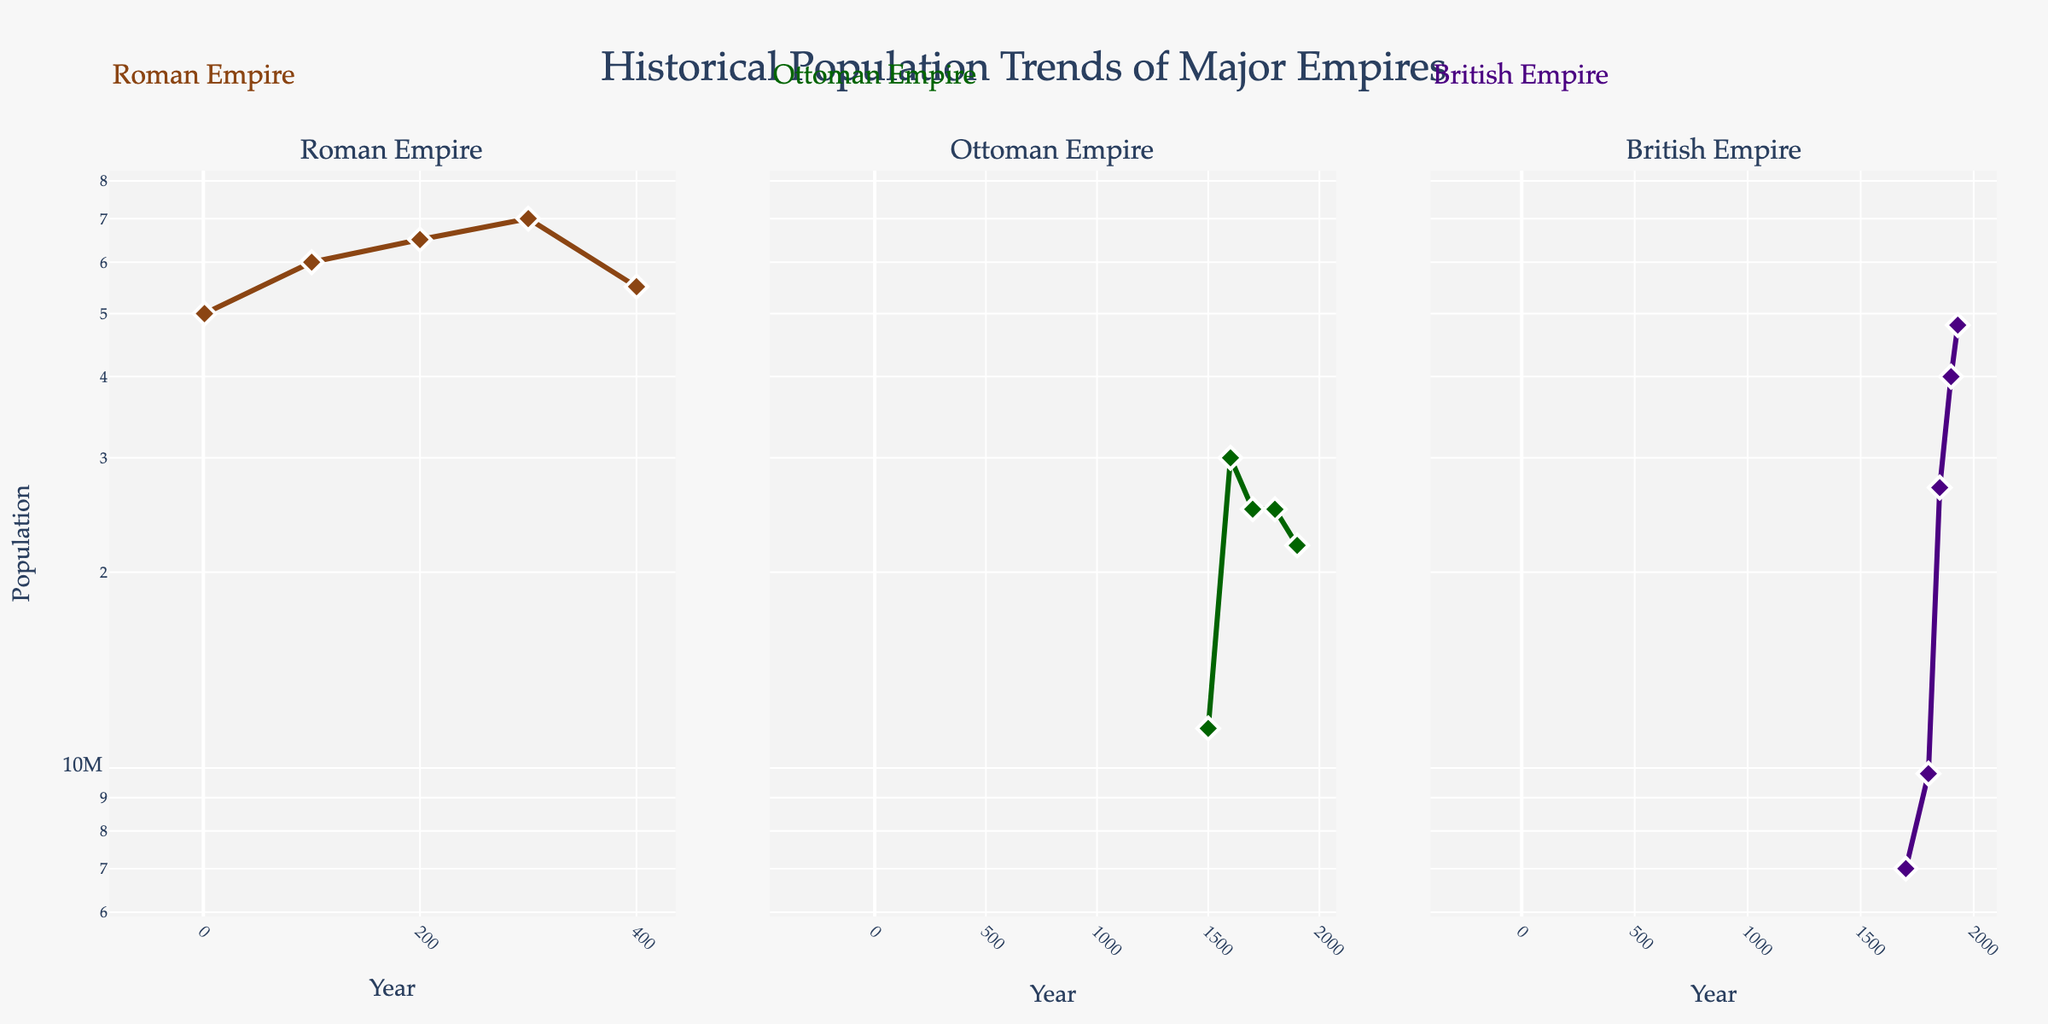How many empires are compared in the figure? The figure has three subplot titles, each representing a different empire. So, we count the subplot titles to find the number of empires.
Answer: Three Which empire has the highest population in its peak year? The Roman Empire's highest population appears to be around 70,000,000, which is higher than the peaks of the Ottoman and British Empires.
Answer: Roman Empire What is the population of the Ottoman Empire in the year 1600? By locating the year 1600 on the x-axis of the Ottoman Empire subplot, we see the population at that point is approximately 30,000,000.
Answer: 30,000,000 Between which years did the British Empire experience the most significant population growth? By examining the British Empire subplot, we notice the most significant jump is between 1800 and 1850, from about 9,800,000 to 27,000,000.
Answer: Between 1800 and 1850 Which empire shows a decline in population in the 1900s? Comparing all three subplots, the Ottoman Empire shows a decline in population from 25,000,000 in 1800 to 22,000,000 in 1900.
Answer: Ottoman Empire How does the population in 100 AD of the Roman Empire compare to the population of the British Empire in 1930? The Roman Empire's population in 100 AD is around 60,000,000, whereas the British Empire's population in 1930 is approximately 48,000,000.
Answer: Roman Empire is higher What is the general trend for the population of the Roman Empire from 1 AD to 400 AD? Analyzing the Roman Empire subplot, the population rises from around 50,000,000 in 1 AD to 70,000,000 in 300 AD and then declines to about 55,000,000 by 400 AD.
Answer: Rise and then fall What is the ratio of the population of the Roman Empire in 300 AD to the population of the Ottoman Empire in 1600? The population of the Roman Empire in 300 AD is 70,000,000, and the Ottoman Empire in 1600 is 30,000,000. Thus, the ratio is 70,000,000:30,000,000 or simplified as 7:3.
Answer: 7:3 What trend is noticeable in all three empires during their respective timelines? Observing the subplots, each empire shows phases of population growth followed by a period of decline or stabilization, indicating a common lifecycle of expansion and contraction.
Answer: Growth followed by decline or stabilization By what factor did the British Empire's population increase from 1700 to 1900? The British Empire's population increased from 7,000,000 in 1700 to 40,000,000 in 1900. The factor is calculated as 40,000,000 / 7,000,000, approximately 5.71.
Answer: Approximately 5.71 